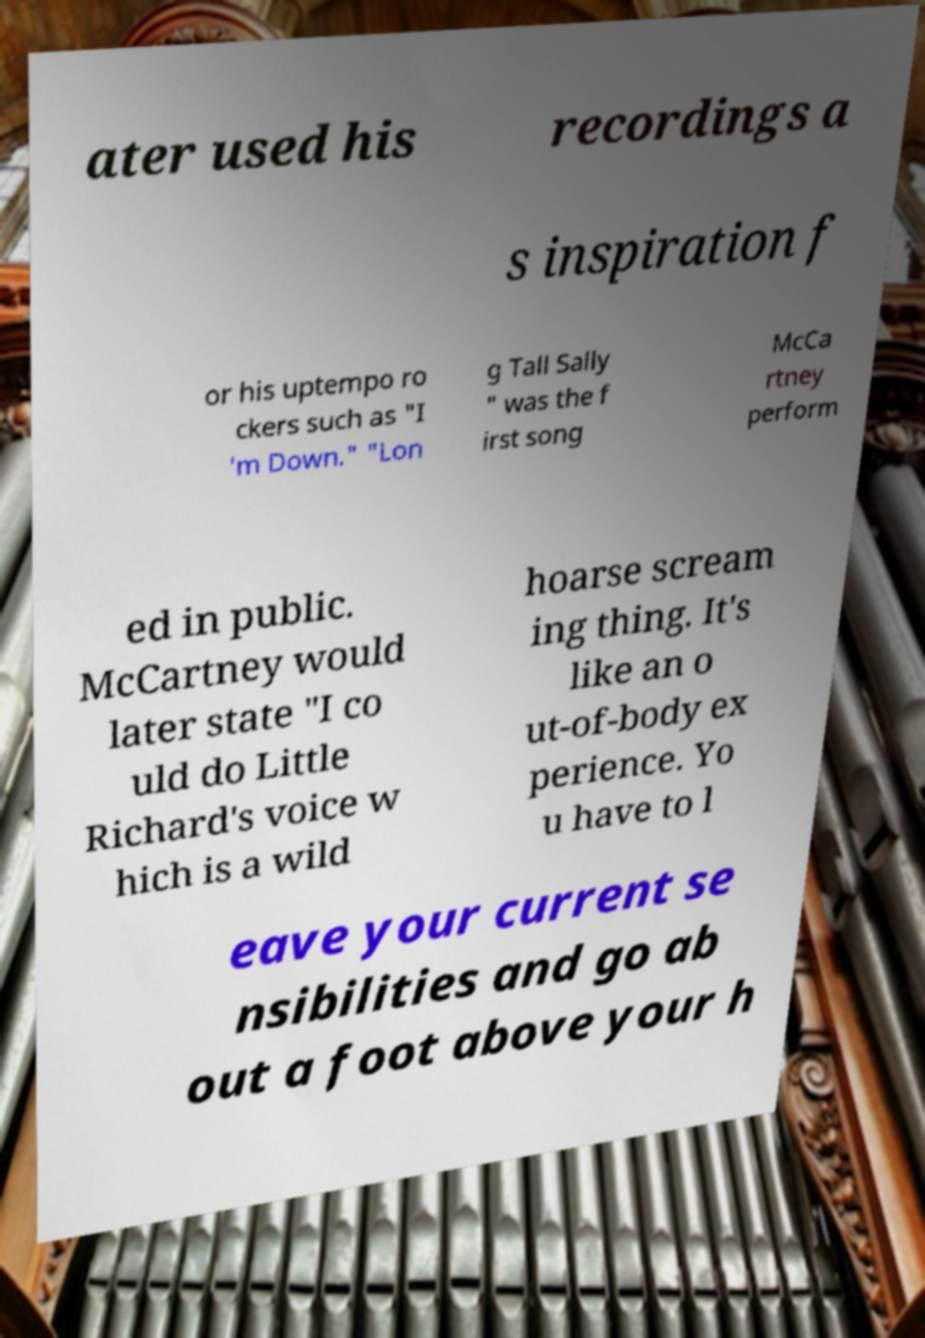Please identify and transcribe the text found in this image. ater used his recordings a s inspiration f or his uptempo ro ckers such as "I 'm Down." "Lon g Tall Sally " was the f irst song McCa rtney perform ed in public. McCartney would later state "I co uld do Little Richard's voice w hich is a wild hoarse scream ing thing. It's like an o ut-of-body ex perience. Yo u have to l eave your current se nsibilities and go ab out a foot above your h 